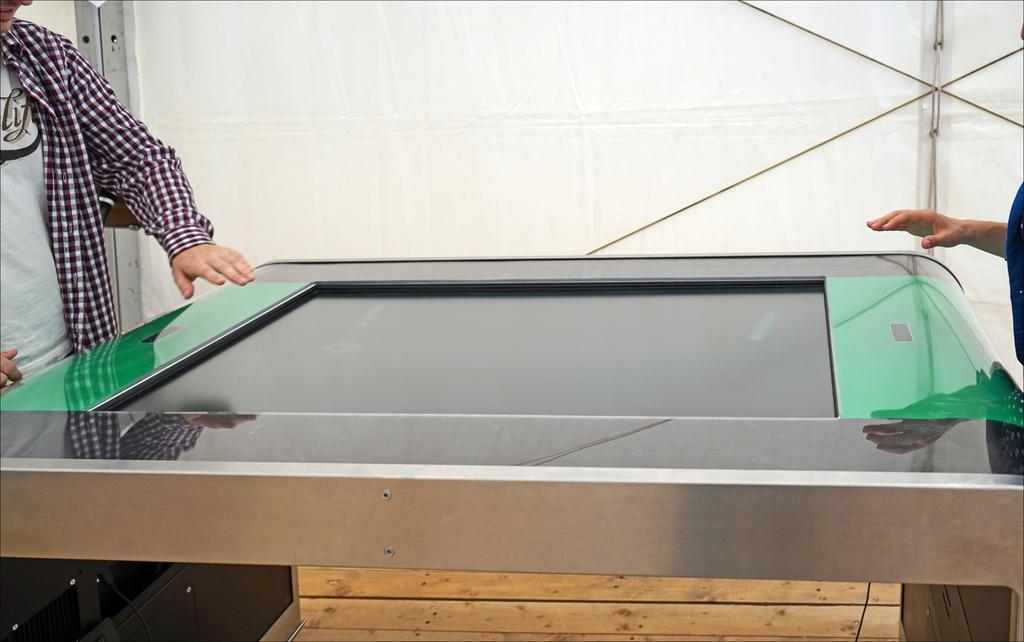What type of furniture is present in the image? There is a table in the image. Can you describe the people in the image? There are people in the image. What material is the floor made of? The floor in the image is made of wood. What is the background of the image? There is a wall in the image. What is the arrangement of the tables in the image? There is another table in front of the people. What is the size of the ray that is swimming in the image? There is no ray present in the image; it only features a table, people, a wooden floor, and a wall. 